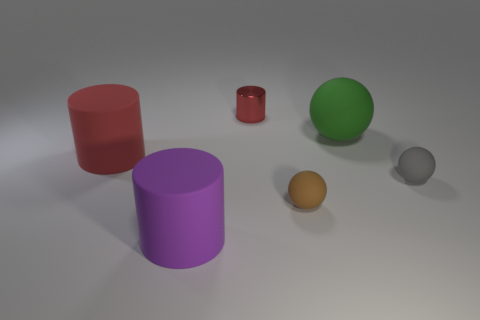Are there an equal number of large green balls that are behind the brown sphere and brown objects that are on the left side of the big purple object?
Give a very brief answer. No. What number of purple objects are either metallic cylinders or tiny spheres?
Provide a short and direct response. 0. There is a shiny object; is it the same color as the big matte cylinder behind the brown sphere?
Keep it short and to the point. Yes. What number of other things are there of the same color as the large rubber sphere?
Make the answer very short. 0. Are there fewer large cylinders than large purple things?
Ensure brevity in your answer.  No. What number of red rubber objects are left of the matte thing that is left of the big matte thing that is in front of the gray matte object?
Make the answer very short. 0. What is the size of the red cylinder that is right of the purple matte cylinder?
Ensure brevity in your answer.  Small. There is a purple matte object left of the tiny red cylinder; is it the same shape as the tiny gray rubber thing?
Keep it short and to the point. No. There is a large green thing that is the same shape as the brown thing; what material is it?
Keep it short and to the point. Rubber. Are there any other things that have the same size as the red matte thing?
Provide a succinct answer. Yes. 